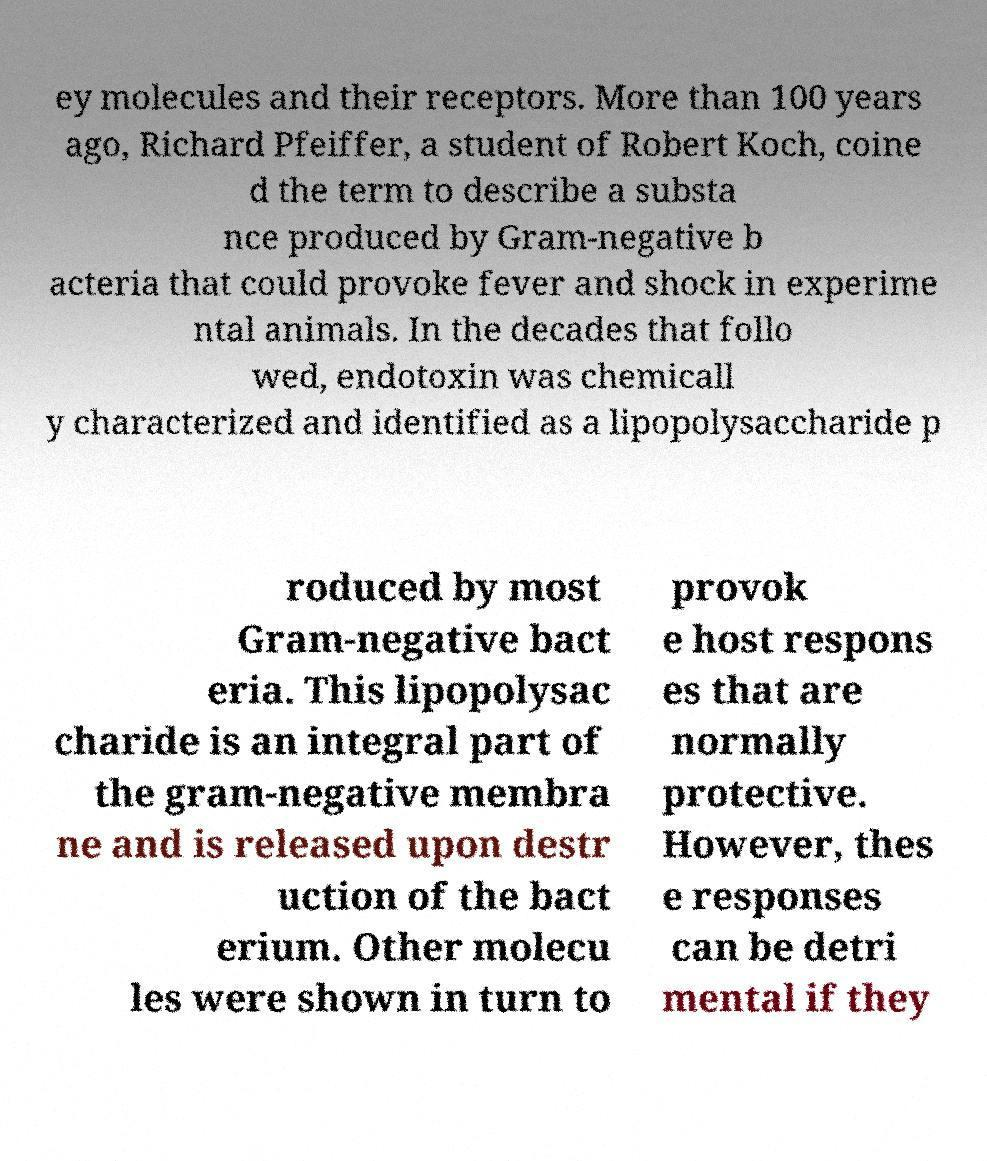I need the written content from this picture converted into text. Can you do that? ey molecules and their receptors. More than 100 years ago, Richard Pfeiffer, a student of Robert Koch, coine d the term to describe a substa nce produced by Gram-negative b acteria that could provoke fever and shock in experime ntal animals. In the decades that follo wed, endotoxin was chemicall y characterized and identified as a lipopolysaccharide p roduced by most Gram-negative bact eria. This lipopolysac charide is an integral part of the gram-negative membra ne and is released upon destr uction of the bact erium. Other molecu les were shown in turn to provok e host respons es that are normally protective. However, thes e responses can be detri mental if they 